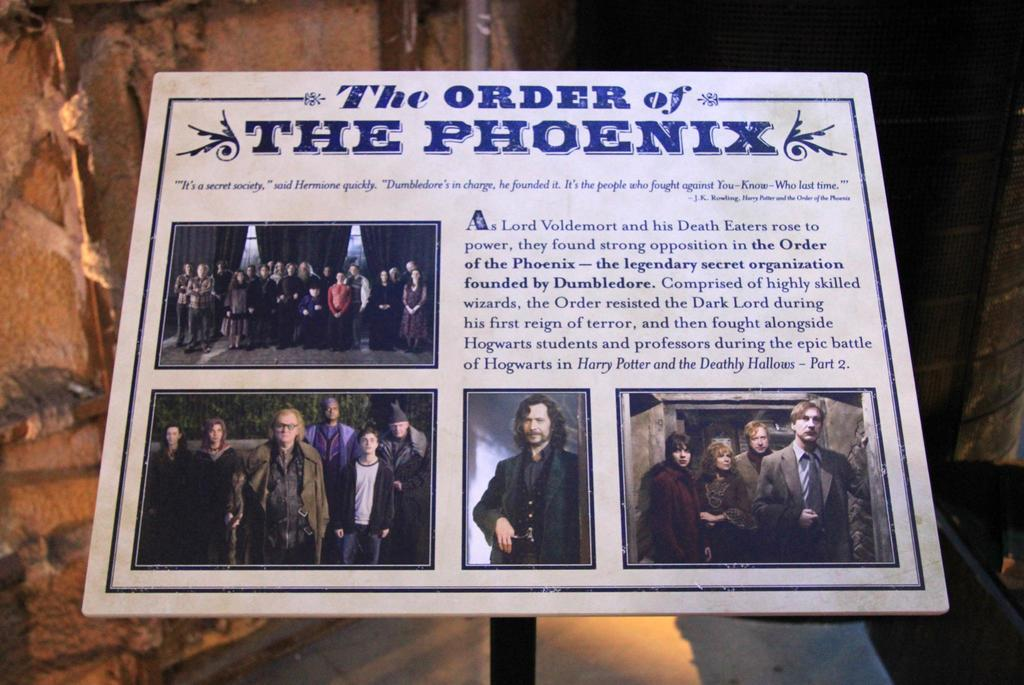<image>
Describe the image concisely. A Harry Potter picture from The Order of the Phoenix 